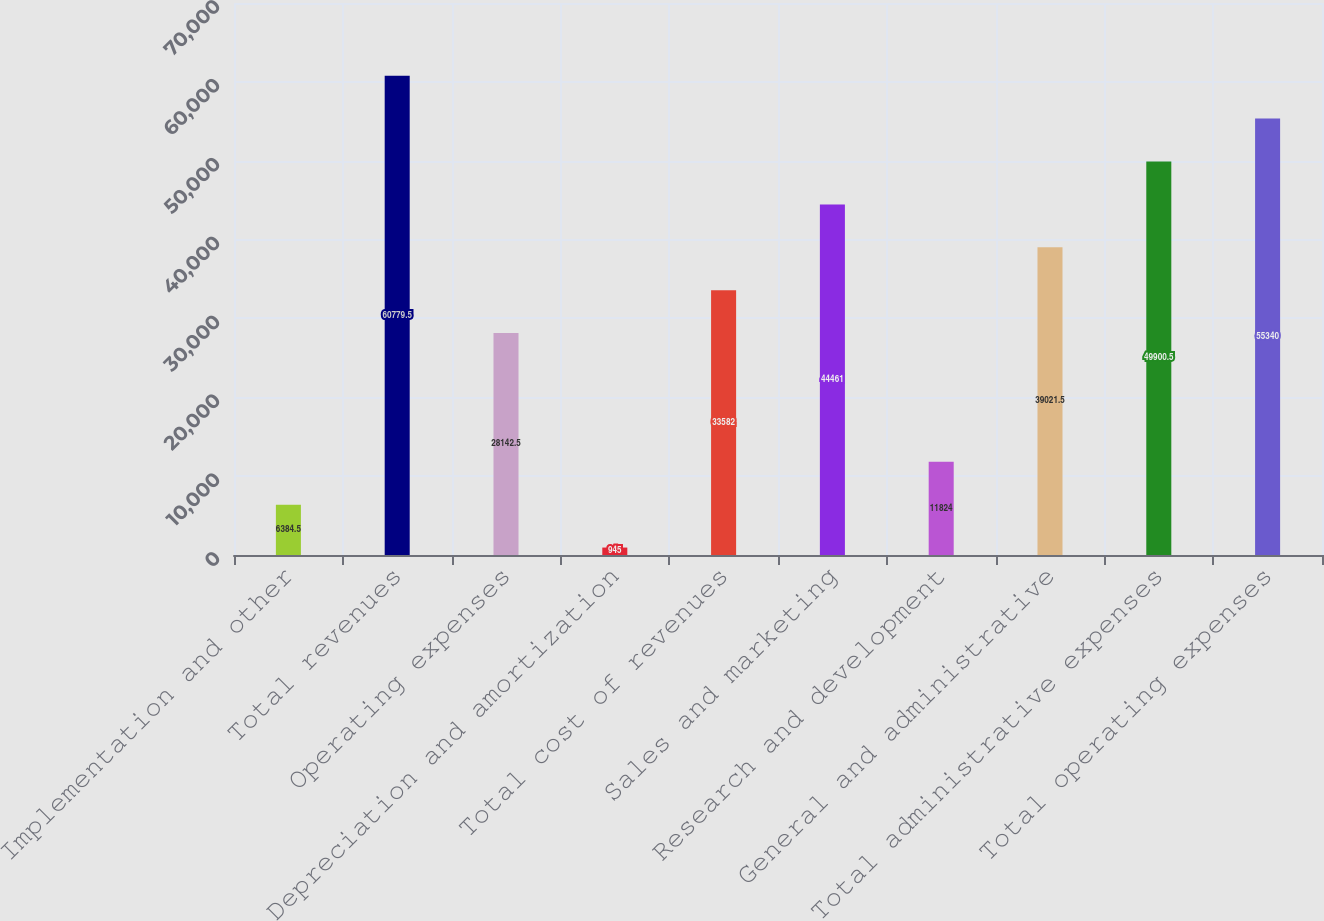Convert chart to OTSL. <chart><loc_0><loc_0><loc_500><loc_500><bar_chart><fcel>Implementation and other<fcel>Total revenues<fcel>Operating expenses<fcel>Depreciation and amortization<fcel>Total cost of revenues<fcel>Sales and marketing<fcel>Research and development<fcel>General and administrative<fcel>Total administrative expenses<fcel>Total operating expenses<nl><fcel>6384.5<fcel>60779.5<fcel>28142.5<fcel>945<fcel>33582<fcel>44461<fcel>11824<fcel>39021.5<fcel>49900.5<fcel>55340<nl></chart> 